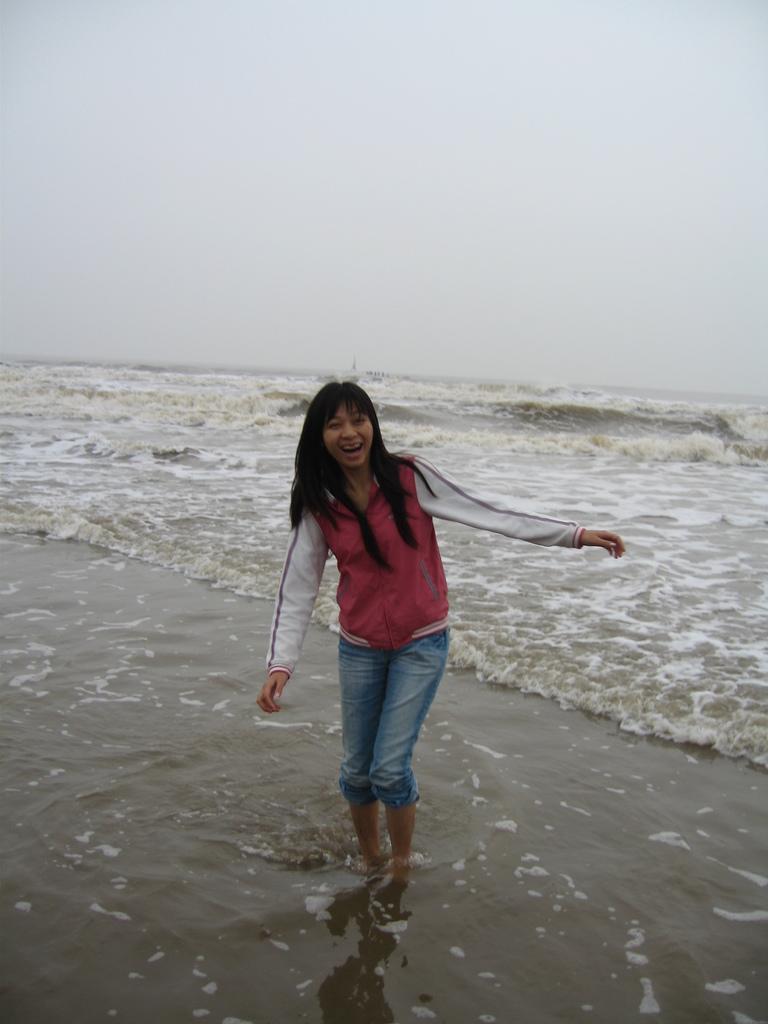In one or two sentences, can you explain what this image depicts? The woman in the middle of the picture wearing a pink and white jacket is standing in the water and this water might be in the sea. She is smiling. At the top of the picture, we see the sky. 